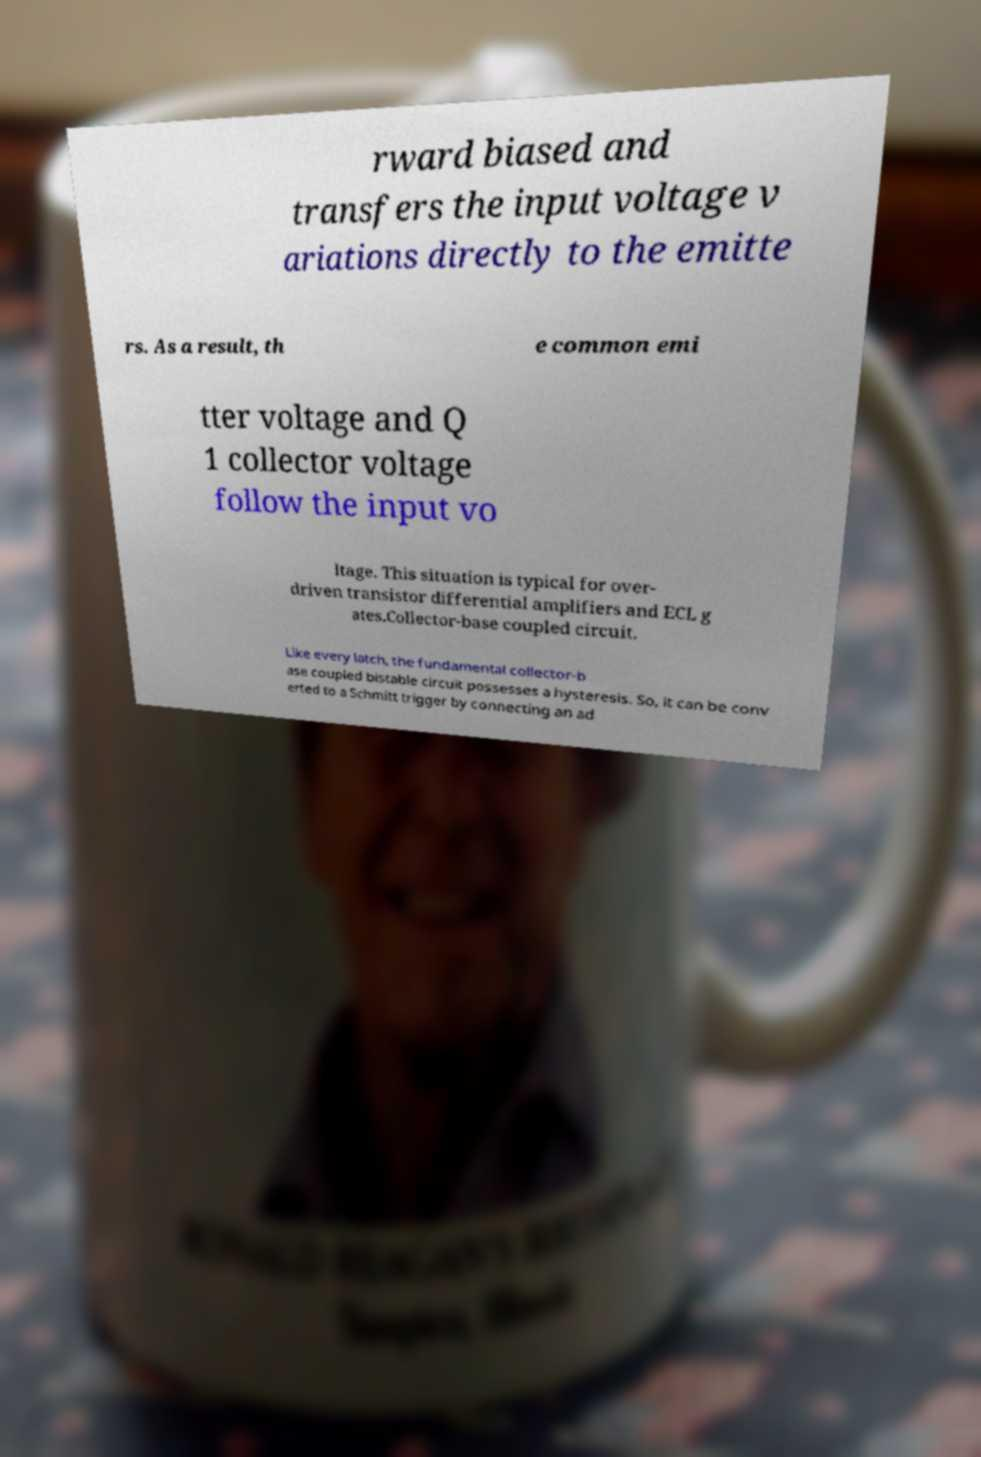Could you extract and type out the text from this image? rward biased and transfers the input voltage v ariations directly to the emitte rs. As a result, th e common emi tter voltage and Q 1 collector voltage follow the input vo ltage. This situation is typical for over- driven transistor differential amplifiers and ECL g ates.Collector-base coupled circuit. Like every latch, the fundamental collector-b ase coupled bistable circuit possesses a hysteresis. So, it can be conv erted to a Schmitt trigger by connecting an ad 